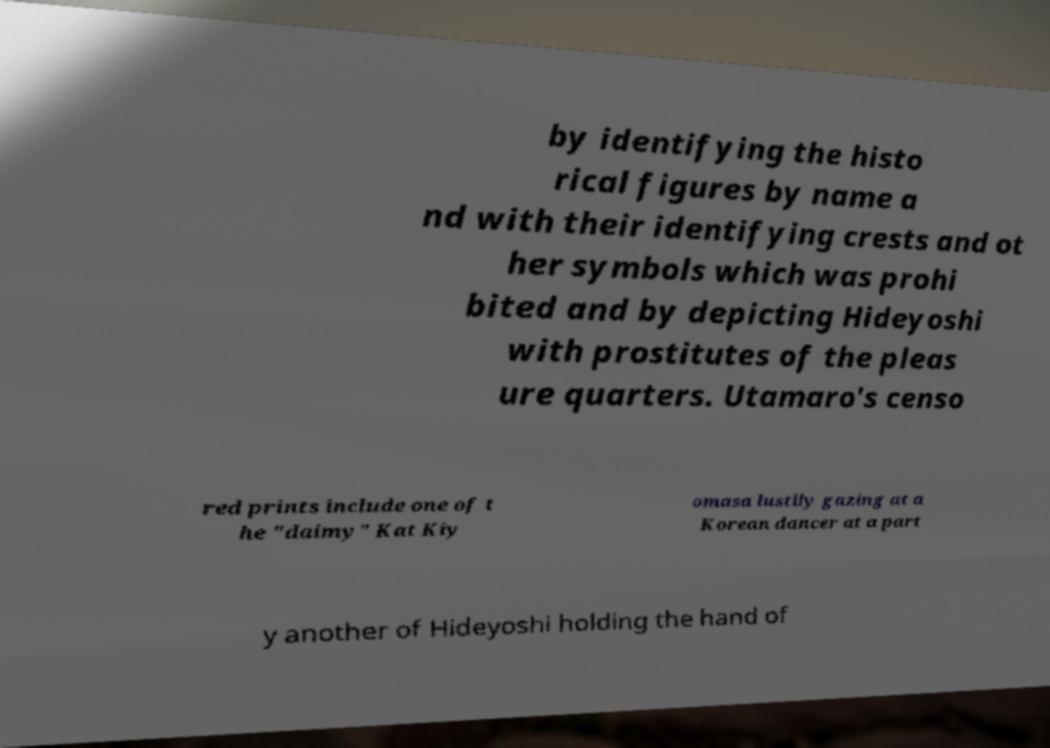I need the written content from this picture converted into text. Can you do that? by identifying the histo rical figures by name a nd with their identifying crests and ot her symbols which was prohi bited and by depicting Hideyoshi with prostitutes of the pleas ure quarters. Utamaro's censo red prints include one of t he "daimy" Kat Kiy omasa lustily gazing at a Korean dancer at a part y another of Hideyoshi holding the hand of 